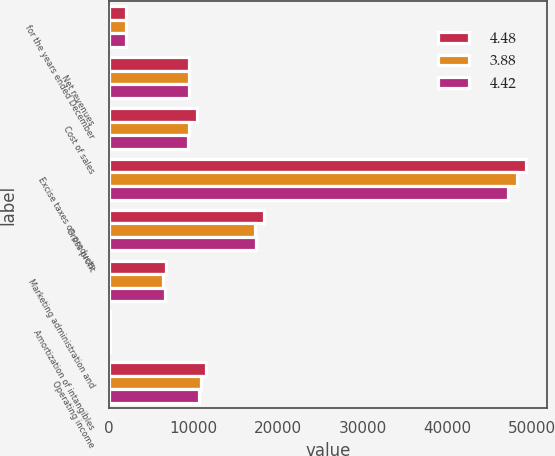<chart> <loc_0><loc_0><loc_500><loc_500><stacked_bar_chart><ecel><fcel>for the years ended December<fcel>Net revenues<fcel>Cost of sales<fcel>Excise taxes on products<fcel>Gross profit<fcel>Marketing administration and<fcel>Amortization of intangibles<fcel>Operating income<nl><fcel>4.48<fcel>2017<fcel>9391<fcel>10432<fcel>49350<fcel>18316<fcel>6725<fcel>88<fcel>11503<nl><fcel>3.88<fcel>2016<fcel>9391<fcel>9391<fcel>48268<fcel>17294<fcel>6405<fcel>74<fcel>10815<nl><fcel>4.42<fcel>2015<fcel>9391<fcel>9365<fcel>47114<fcel>17429<fcel>6656<fcel>82<fcel>10623<nl></chart> 